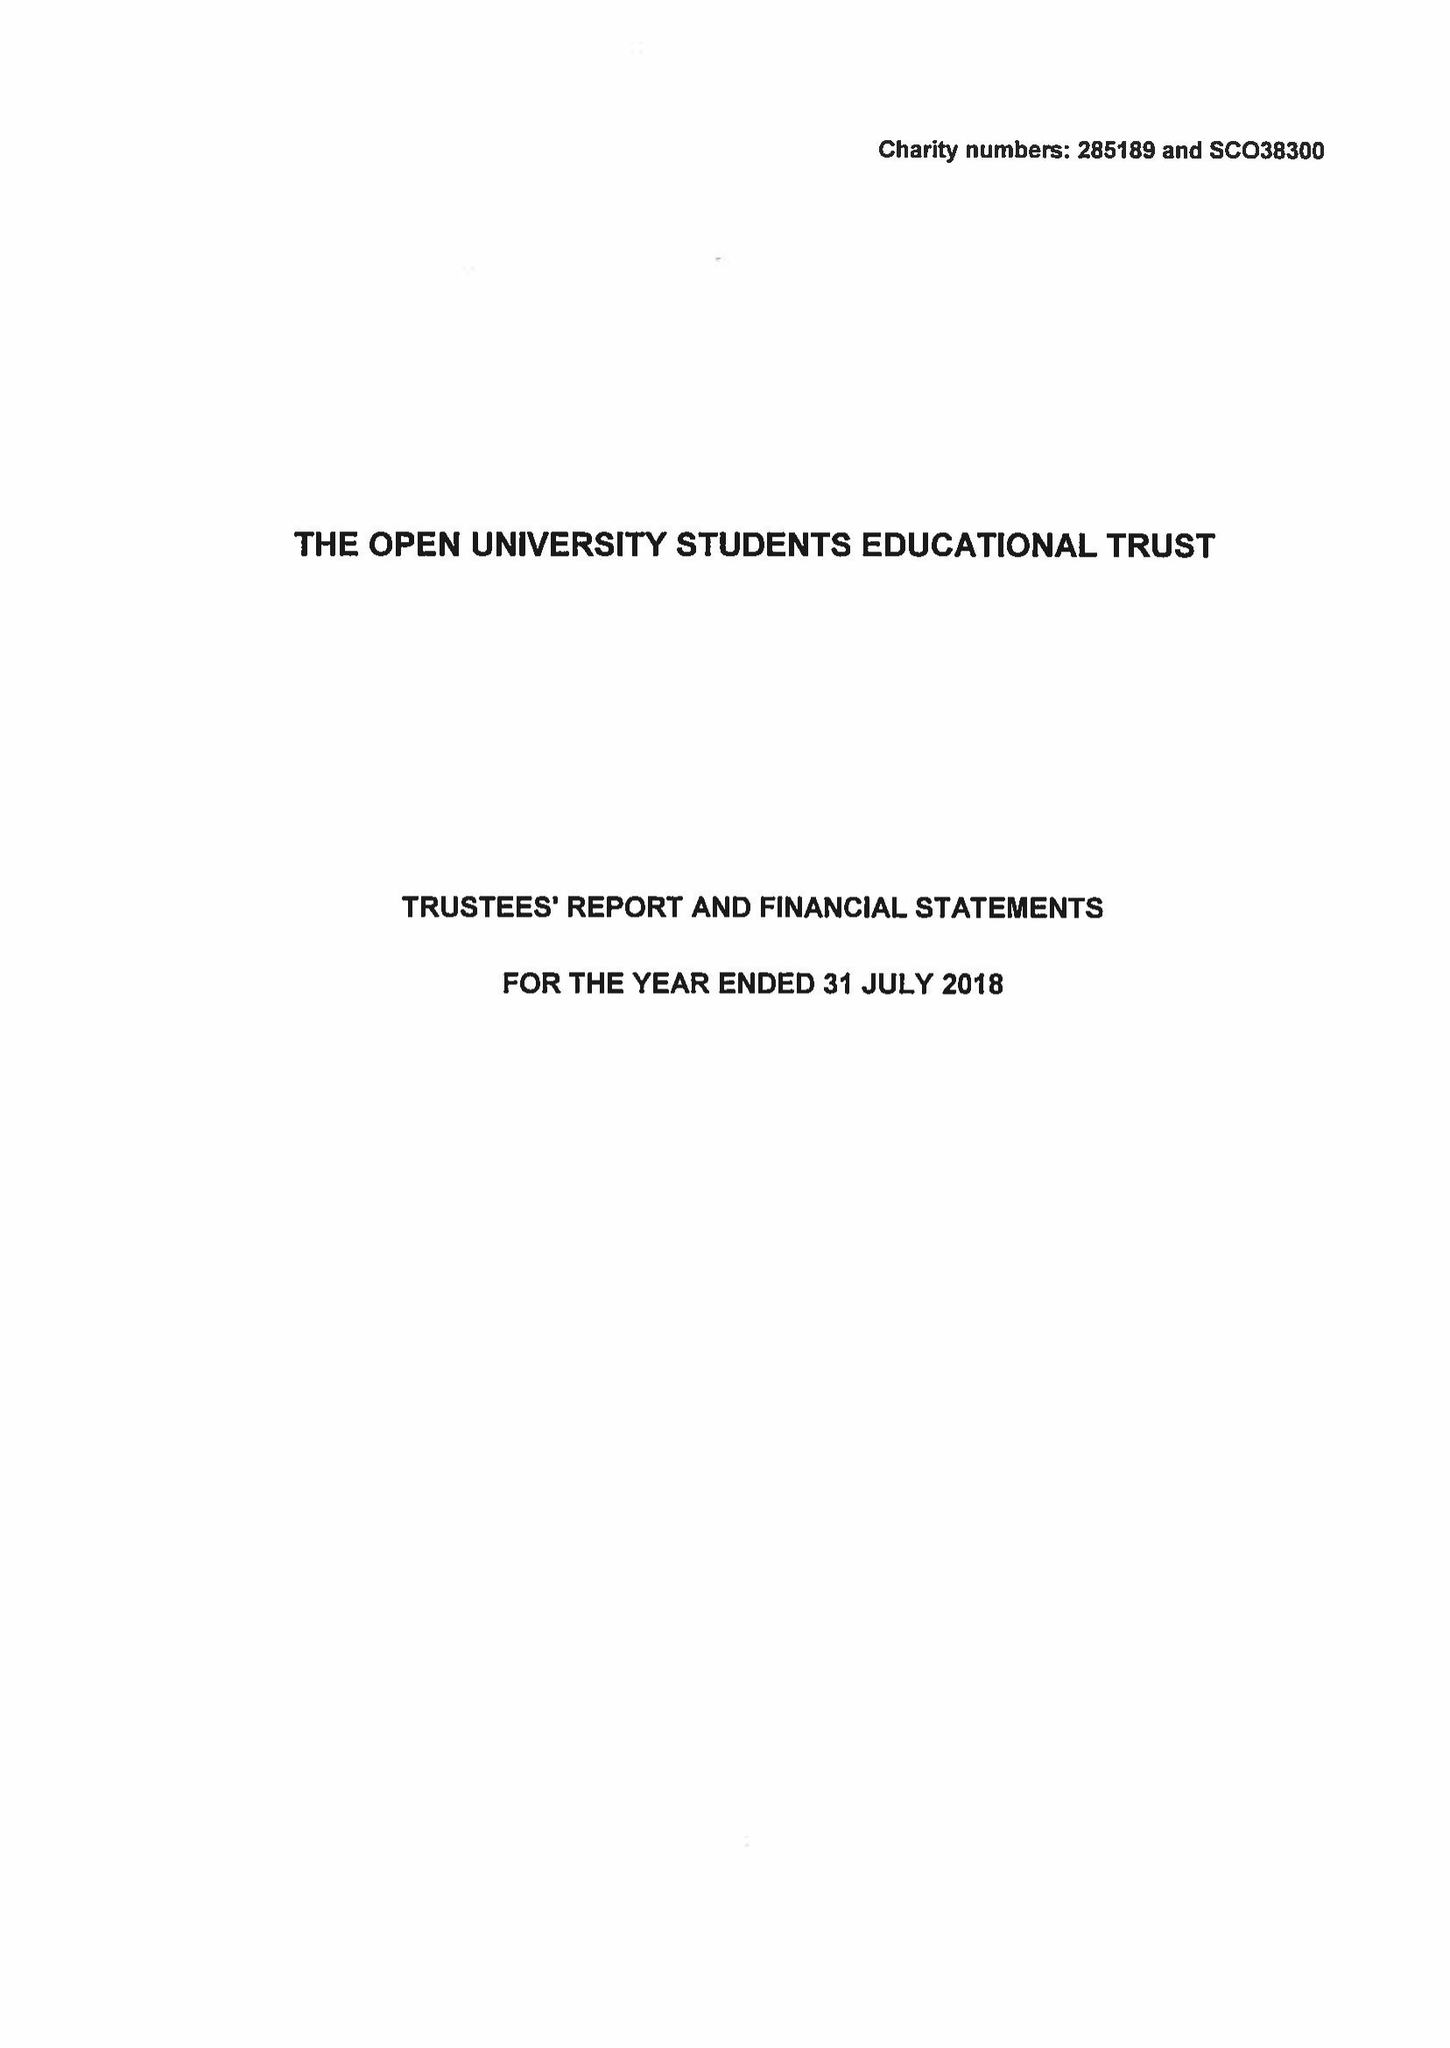What is the value for the charity_name?
Answer the question using a single word or phrase. The Open University Students Educational Trust 